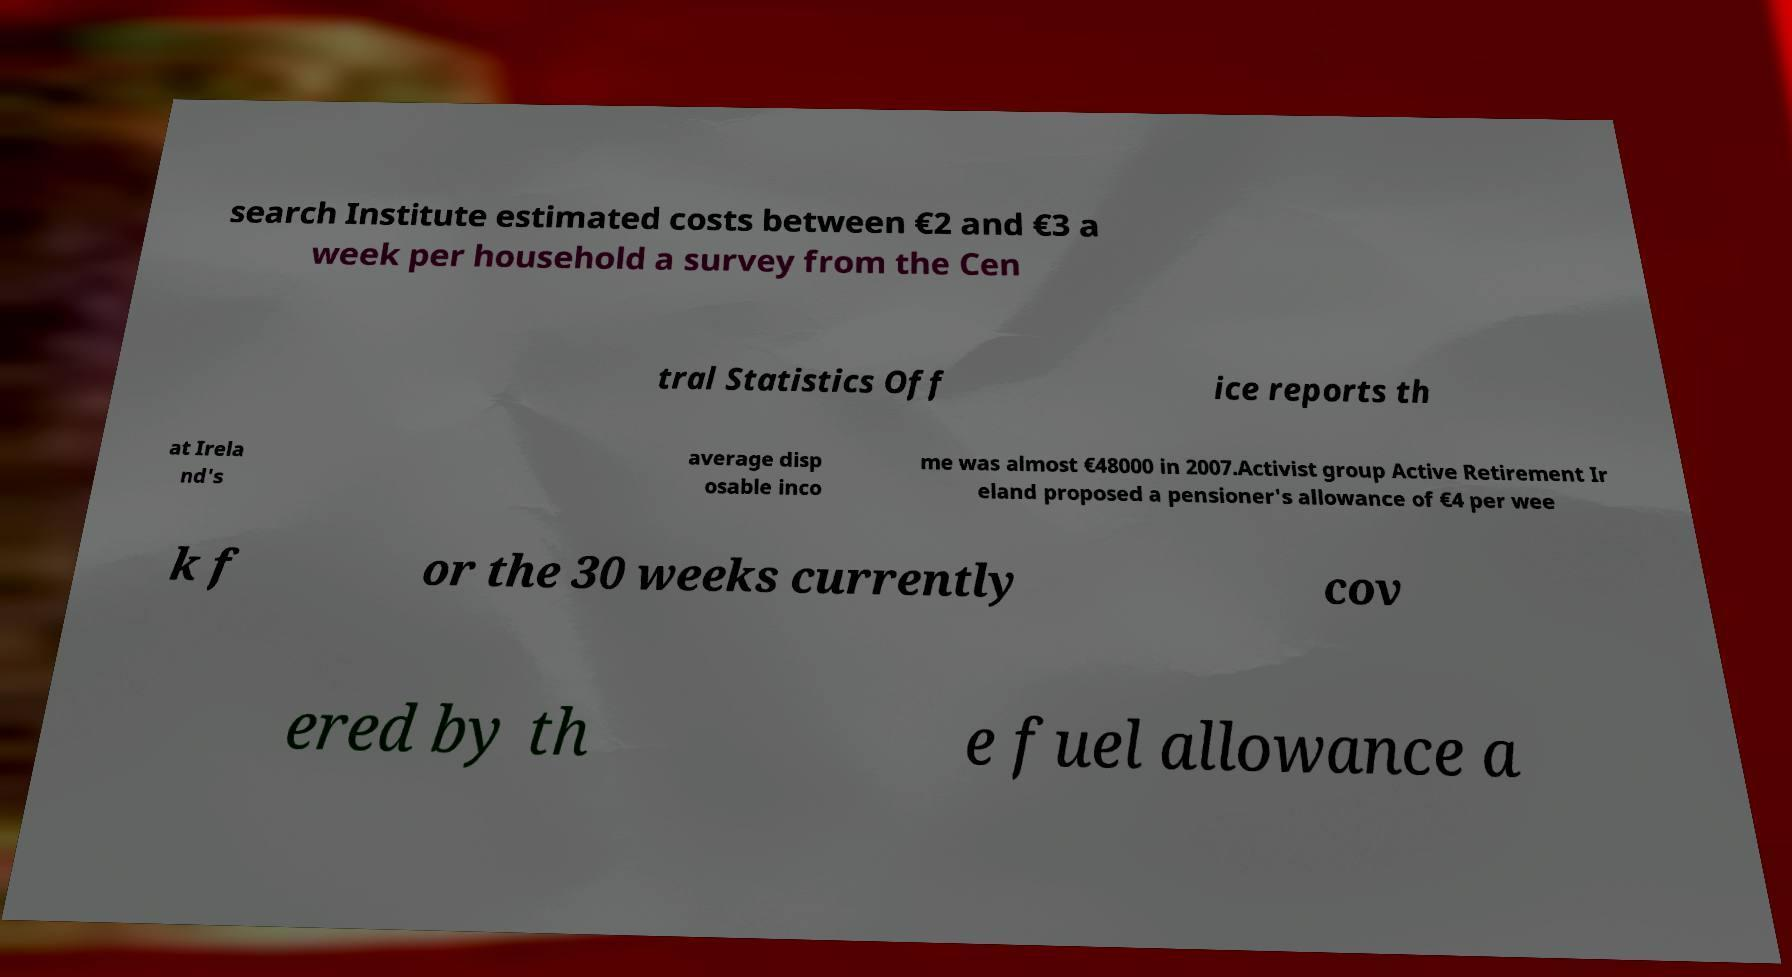Please read and relay the text visible in this image. What does it say? search Institute estimated costs between €2 and €3 a week per household a survey from the Cen tral Statistics Off ice reports th at Irela nd's average disp osable inco me was almost €48000 in 2007.Activist group Active Retirement Ir eland proposed a pensioner's allowance of €4 per wee k f or the 30 weeks currently cov ered by th e fuel allowance a 